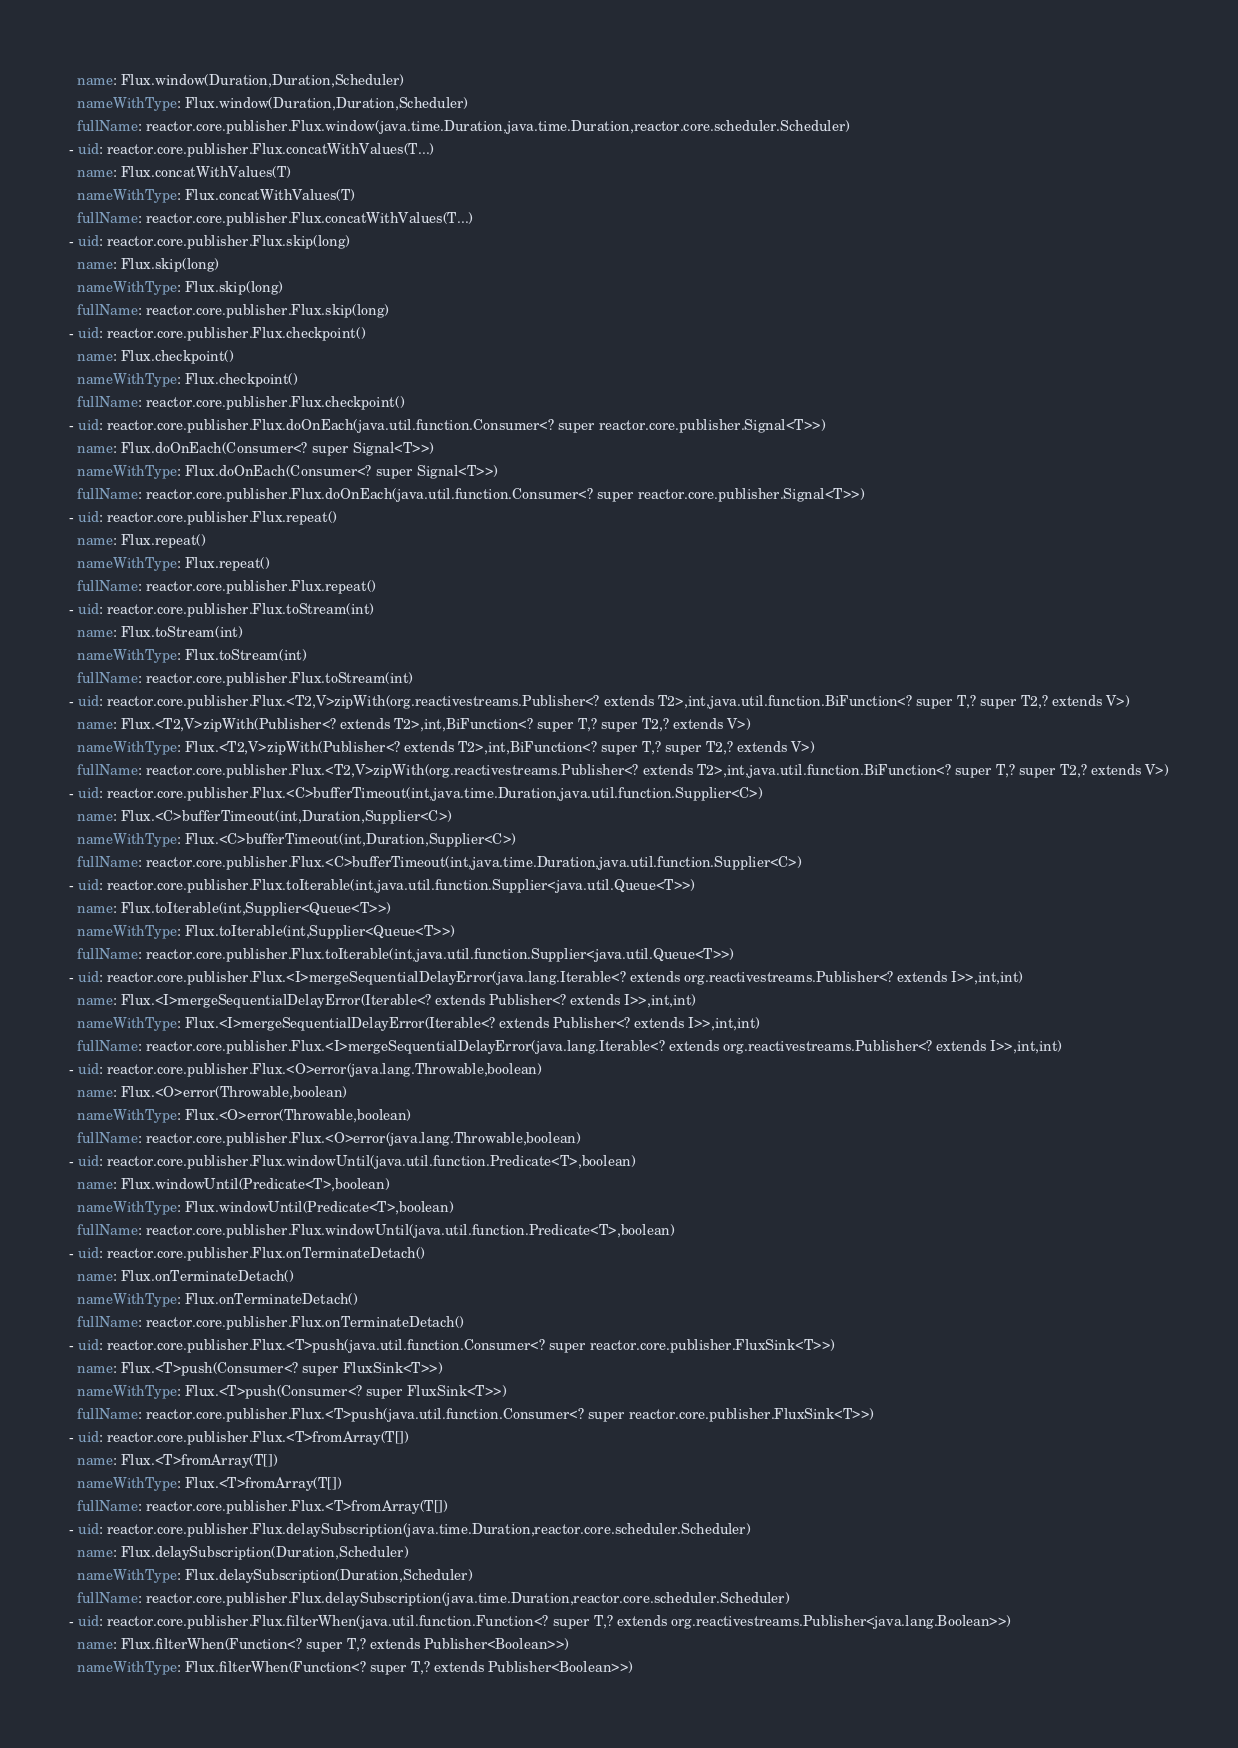<code> <loc_0><loc_0><loc_500><loc_500><_YAML_>  name: Flux.window(Duration,Duration,Scheduler)
  nameWithType: Flux.window(Duration,Duration,Scheduler)
  fullName: reactor.core.publisher.Flux.window(java.time.Duration,java.time.Duration,reactor.core.scheduler.Scheduler)
- uid: reactor.core.publisher.Flux.concatWithValues(T...)
  name: Flux.concatWithValues(T)
  nameWithType: Flux.concatWithValues(T)
  fullName: reactor.core.publisher.Flux.concatWithValues(T...)
- uid: reactor.core.publisher.Flux.skip(long)
  name: Flux.skip(long)
  nameWithType: Flux.skip(long)
  fullName: reactor.core.publisher.Flux.skip(long)
- uid: reactor.core.publisher.Flux.checkpoint()
  name: Flux.checkpoint()
  nameWithType: Flux.checkpoint()
  fullName: reactor.core.publisher.Flux.checkpoint()
- uid: reactor.core.publisher.Flux.doOnEach(java.util.function.Consumer<? super reactor.core.publisher.Signal<T>>)
  name: Flux.doOnEach(Consumer<? super Signal<T>>)
  nameWithType: Flux.doOnEach(Consumer<? super Signal<T>>)
  fullName: reactor.core.publisher.Flux.doOnEach(java.util.function.Consumer<? super reactor.core.publisher.Signal<T>>)
- uid: reactor.core.publisher.Flux.repeat()
  name: Flux.repeat()
  nameWithType: Flux.repeat()
  fullName: reactor.core.publisher.Flux.repeat()
- uid: reactor.core.publisher.Flux.toStream(int)
  name: Flux.toStream(int)
  nameWithType: Flux.toStream(int)
  fullName: reactor.core.publisher.Flux.toStream(int)
- uid: reactor.core.publisher.Flux.<T2,V>zipWith(org.reactivestreams.Publisher<? extends T2>,int,java.util.function.BiFunction<? super T,? super T2,? extends V>)
  name: Flux.<T2,V>zipWith(Publisher<? extends T2>,int,BiFunction<? super T,? super T2,? extends V>)
  nameWithType: Flux.<T2,V>zipWith(Publisher<? extends T2>,int,BiFunction<? super T,? super T2,? extends V>)
  fullName: reactor.core.publisher.Flux.<T2,V>zipWith(org.reactivestreams.Publisher<? extends T2>,int,java.util.function.BiFunction<? super T,? super T2,? extends V>)
- uid: reactor.core.publisher.Flux.<C>bufferTimeout(int,java.time.Duration,java.util.function.Supplier<C>)
  name: Flux.<C>bufferTimeout(int,Duration,Supplier<C>)
  nameWithType: Flux.<C>bufferTimeout(int,Duration,Supplier<C>)
  fullName: reactor.core.publisher.Flux.<C>bufferTimeout(int,java.time.Duration,java.util.function.Supplier<C>)
- uid: reactor.core.publisher.Flux.toIterable(int,java.util.function.Supplier<java.util.Queue<T>>)
  name: Flux.toIterable(int,Supplier<Queue<T>>)
  nameWithType: Flux.toIterable(int,Supplier<Queue<T>>)
  fullName: reactor.core.publisher.Flux.toIterable(int,java.util.function.Supplier<java.util.Queue<T>>)
- uid: reactor.core.publisher.Flux.<I>mergeSequentialDelayError(java.lang.Iterable<? extends org.reactivestreams.Publisher<? extends I>>,int,int)
  name: Flux.<I>mergeSequentialDelayError(Iterable<? extends Publisher<? extends I>>,int,int)
  nameWithType: Flux.<I>mergeSequentialDelayError(Iterable<? extends Publisher<? extends I>>,int,int)
  fullName: reactor.core.publisher.Flux.<I>mergeSequentialDelayError(java.lang.Iterable<? extends org.reactivestreams.Publisher<? extends I>>,int,int)
- uid: reactor.core.publisher.Flux.<O>error(java.lang.Throwable,boolean)
  name: Flux.<O>error(Throwable,boolean)
  nameWithType: Flux.<O>error(Throwable,boolean)
  fullName: reactor.core.publisher.Flux.<O>error(java.lang.Throwable,boolean)
- uid: reactor.core.publisher.Flux.windowUntil(java.util.function.Predicate<T>,boolean)
  name: Flux.windowUntil(Predicate<T>,boolean)
  nameWithType: Flux.windowUntil(Predicate<T>,boolean)
  fullName: reactor.core.publisher.Flux.windowUntil(java.util.function.Predicate<T>,boolean)
- uid: reactor.core.publisher.Flux.onTerminateDetach()
  name: Flux.onTerminateDetach()
  nameWithType: Flux.onTerminateDetach()
  fullName: reactor.core.publisher.Flux.onTerminateDetach()
- uid: reactor.core.publisher.Flux.<T>push(java.util.function.Consumer<? super reactor.core.publisher.FluxSink<T>>)
  name: Flux.<T>push(Consumer<? super FluxSink<T>>)
  nameWithType: Flux.<T>push(Consumer<? super FluxSink<T>>)
  fullName: reactor.core.publisher.Flux.<T>push(java.util.function.Consumer<? super reactor.core.publisher.FluxSink<T>>)
- uid: reactor.core.publisher.Flux.<T>fromArray(T[])
  name: Flux.<T>fromArray(T[])
  nameWithType: Flux.<T>fromArray(T[])
  fullName: reactor.core.publisher.Flux.<T>fromArray(T[])
- uid: reactor.core.publisher.Flux.delaySubscription(java.time.Duration,reactor.core.scheduler.Scheduler)
  name: Flux.delaySubscription(Duration,Scheduler)
  nameWithType: Flux.delaySubscription(Duration,Scheduler)
  fullName: reactor.core.publisher.Flux.delaySubscription(java.time.Duration,reactor.core.scheduler.Scheduler)
- uid: reactor.core.publisher.Flux.filterWhen(java.util.function.Function<? super T,? extends org.reactivestreams.Publisher<java.lang.Boolean>>)
  name: Flux.filterWhen(Function<? super T,? extends Publisher<Boolean>>)
  nameWithType: Flux.filterWhen(Function<? super T,? extends Publisher<Boolean>>)</code> 